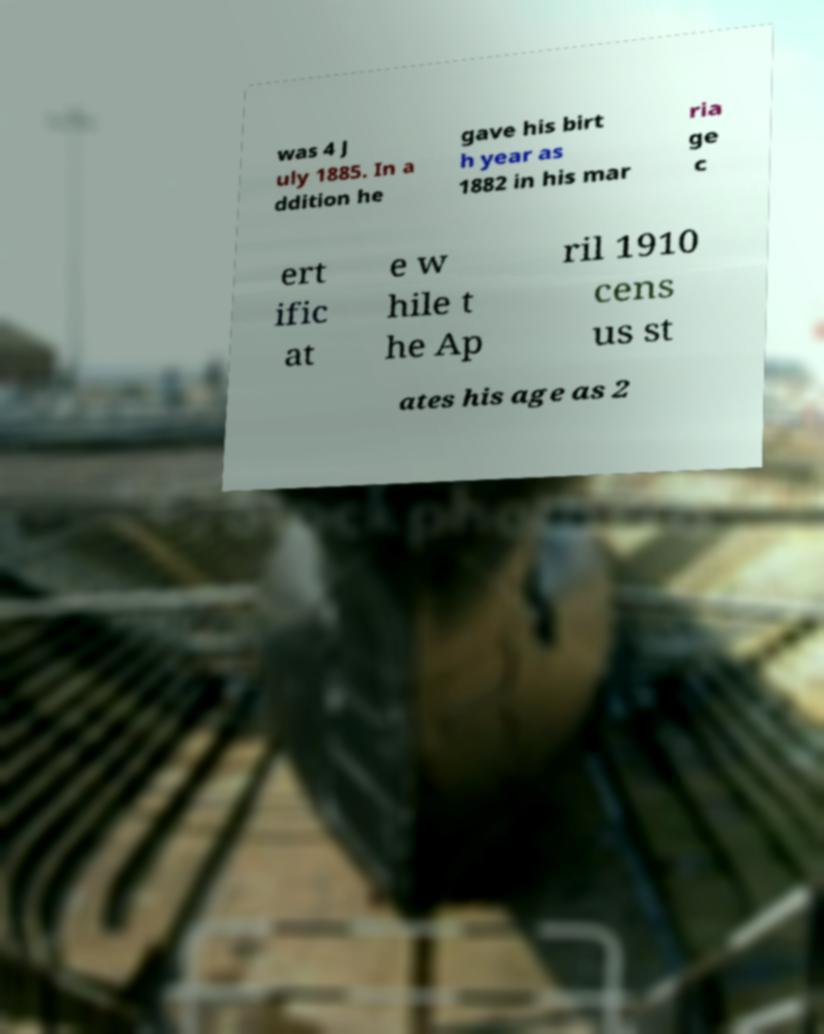Please identify and transcribe the text found in this image. was 4 J uly 1885. In a ddition he gave his birt h year as 1882 in his mar ria ge c ert ific at e w hile t he Ap ril 1910 cens us st ates his age as 2 